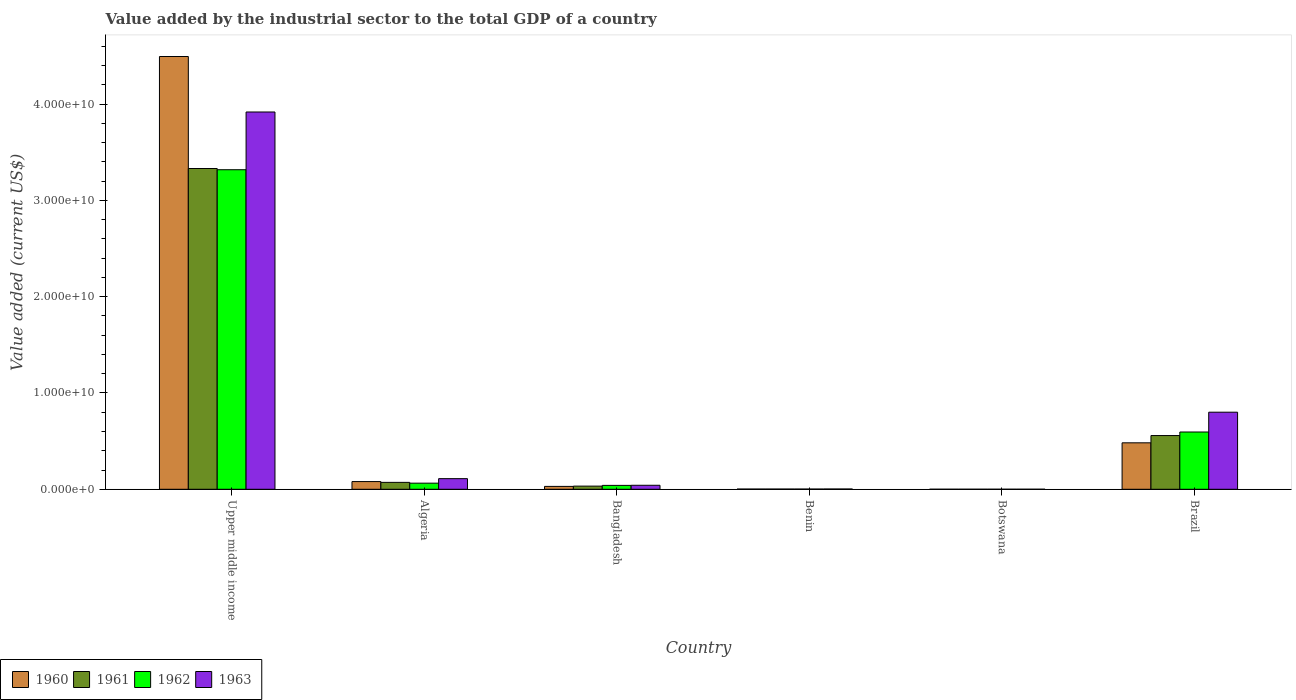Are the number of bars per tick equal to the number of legend labels?
Provide a short and direct response. Yes. Are the number of bars on each tick of the X-axis equal?
Your answer should be very brief. Yes. How many bars are there on the 6th tick from the left?
Your answer should be compact. 4. What is the label of the 4th group of bars from the left?
Ensure brevity in your answer.  Benin. In how many cases, is the number of bars for a given country not equal to the number of legend labels?
Your response must be concise. 0. What is the value added by the industrial sector to the total GDP in 1963 in Botswana?
Offer a terse response. 4.04e+06. Across all countries, what is the maximum value added by the industrial sector to the total GDP in 1961?
Your response must be concise. 3.33e+1. Across all countries, what is the minimum value added by the industrial sector to the total GDP in 1962?
Keep it short and to the point. 4.05e+06. In which country was the value added by the industrial sector to the total GDP in 1962 maximum?
Offer a terse response. Upper middle income. In which country was the value added by the industrial sector to the total GDP in 1960 minimum?
Offer a very short reply. Botswana. What is the total value added by the industrial sector to the total GDP in 1962 in the graph?
Make the answer very short. 4.02e+1. What is the difference between the value added by the industrial sector to the total GDP in 1961 in Brazil and that in Upper middle income?
Offer a terse response. -2.77e+1. What is the difference between the value added by the industrial sector to the total GDP in 1960 in Upper middle income and the value added by the industrial sector to the total GDP in 1963 in Brazil?
Your answer should be compact. 3.69e+1. What is the average value added by the industrial sector to the total GDP in 1960 per country?
Your answer should be very brief. 8.48e+09. What is the difference between the value added by the industrial sector to the total GDP of/in 1960 and value added by the industrial sector to the total GDP of/in 1962 in Upper middle income?
Give a very brief answer. 1.18e+1. In how many countries, is the value added by the industrial sector to the total GDP in 1960 greater than 28000000000 US$?
Ensure brevity in your answer.  1. What is the ratio of the value added by the industrial sector to the total GDP in 1963 in Benin to that in Upper middle income?
Your answer should be very brief. 0. What is the difference between the highest and the second highest value added by the industrial sector to the total GDP in 1960?
Make the answer very short. 4.02e+09. What is the difference between the highest and the lowest value added by the industrial sector to the total GDP in 1962?
Offer a terse response. 3.32e+1. In how many countries, is the value added by the industrial sector to the total GDP in 1961 greater than the average value added by the industrial sector to the total GDP in 1961 taken over all countries?
Your answer should be compact. 1. Is it the case that in every country, the sum of the value added by the industrial sector to the total GDP in 1961 and value added by the industrial sector to the total GDP in 1962 is greater than the sum of value added by the industrial sector to the total GDP in 1960 and value added by the industrial sector to the total GDP in 1963?
Provide a short and direct response. No. Are the values on the major ticks of Y-axis written in scientific E-notation?
Your response must be concise. Yes. Does the graph contain any zero values?
Give a very brief answer. No. Where does the legend appear in the graph?
Your answer should be very brief. Bottom left. How are the legend labels stacked?
Give a very brief answer. Horizontal. What is the title of the graph?
Offer a terse response. Value added by the industrial sector to the total GDP of a country. Does "1964" appear as one of the legend labels in the graph?
Keep it short and to the point. No. What is the label or title of the X-axis?
Keep it short and to the point. Country. What is the label or title of the Y-axis?
Your answer should be very brief. Value added (current US$). What is the Value added (current US$) of 1960 in Upper middle income?
Your answer should be compact. 4.49e+1. What is the Value added (current US$) in 1961 in Upper middle income?
Make the answer very short. 3.33e+1. What is the Value added (current US$) of 1962 in Upper middle income?
Your answer should be very brief. 3.32e+1. What is the Value added (current US$) in 1963 in Upper middle income?
Provide a short and direct response. 3.92e+1. What is the Value added (current US$) in 1960 in Algeria?
Keep it short and to the point. 8.00e+08. What is the Value added (current US$) in 1961 in Algeria?
Provide a succinct answer. 7.17e+08. What is the Value added (current US$) of 1962 in Algeria?
Provide a succinct answer. 6.34e+08. What is the Value added (current US$) in 1963 in Algeria?
Provide a short and direct response. 1.10e+09. What is the Value added (current US$) in 1960 in Bangladesh?
Your response must be concise. 2.98e+08. What is the Value added (current US$) in 1961 in Bangladesh?
Ensure brevity in your answer.  3.27e+08. What is the Value added (current US$) in 1962 in Bangladesh?
Provide a short and direct response. 4.05e+08. What is the Value added (current US$) of 1963 in Bangladesh?
Keep it short and to the point. 4.15e+08. What is the Value added (current US$) in 1960 in Benin?
Ensure brevity in your answer.  2.31e+07. What is the Value added (current US$) of 1961 in Benin?
Offer a very short reply. 2.31e+07. What is the Value added (current US$) of 1962 in Benin?
Ensure brevity in your answer.  2.32e+07. What is the Value added (current US$) in 1963 in Benin?
Give a very brief answer. 2.91e+07. What is the Value added (current US$) of 1960 in Botswana?
Offer a very short reply. 4.05e+06. What is the Value added (current US$) of 1961 in Botswana?
Your response must be concise. 4.05e+06. What is the Value added (current US$) in 1962 in Botswana?
Offer a very short reply. 4.05e+06. What is the Value added (current US$) in 1963 in Botswana?
Make the answer very short. 4.04e+06. What is the Value added (current US$) of 1960 in Brazil?
Your response must be concise. 4.82e+09. What is the Value added (current US$) in 1961 in Brazil?
Your answer should be very brief. 5.58e+09. What is the Value added (current US$) of 1962 in Brazil?
Provide a succinct answer. 5.95e+09. What is the Value added (current US$) of 1963 in Brazil?
Offer a terse response. 8.00e+09. Across all countries, what is the maximum Value added (current US$) of 1960?
Offer a terse response. 4.49e+1. Across all countries, what is the maximum Value added (current US$) of 1961?
Give a very brief answer. 3.33e+1. Across all countries, what is the maximum Value added (current US$) in 1962?
Make the answer very short. 3.32e+1. Across all countries, what is the maximum Value added (current US$) of 1963?
Make the answer very short. 3.92e+1. Across all countries, what is the minimum Value added (current US$) in 1960?
Make the answer very short. 4.05e+06. Across all countries, what is the minimum Value added (current US$) in 1961?
Your response must be concise. 4.05e+06. Across all countries, what is the minimum Value added (current US$) in 1962?
Ensure brevity in your answer.  4.05e+06. Across all countries, what is the minimum Value added (current US$) in 1963?
Offer a terse response. 4.04e+06. What is the total Value added (current US$) in 1960 in the graph?
Provide a short and direct response. 5.09e+1. What is the total Value added (current US$) of 1961 in the graph?
Your answer should be very brief. 4.00e+1. What is the total Value added (current US$) in 1962 in the graph?
Give a very brief answer. 4.02e+1. What is the total Value added (current US$) in 1963 in the graph?
Your response must be concise. 4.87e+1. What is the difference between the Value added (current US$) of 1960 in Upper middle income and that in Algeria?
Provide a short and direct response. 4.41e+1. What is the difference between the Value added (current US$) in 1961 in Upper middle income and that in Algeria?
Offer a terse response. 3.26e+1. What is the difference between the Value added (current US$) of 1962 in Upper middle income and that in Algeria?
Your response must be concise. 3.25e+1. What is the difference between the Value added (current US$) in 1963 in Upper middle income and that in Algeria?
Provide a succinct answer. 3.81e+1. What is the difference between the Value added (current US$) in 1960 in Upper middle income and that in Bangladesh?
Make the answer very short. 4.46e+1. What is the difference between the Value added (current US$) of 1961 in Upper middle income and that in Bangladesh?
Provide a succinct answer. 3.30e+1. What is the difference between the Value added (current US$) in 1962 in Upper middle income and that in Bangladesh?
Give a very brief answer. 3.28e+1. What is the difference between the Value added (current US$) of 1963 in Upper middle income and that in Bangladesh?
Your response must be concise. 3.88e+1. What is the difference between the Value added (current US$) in 1960 in Upper middle income and that in Benin?
Your answer should be compact. 4.49e+1. What is the difference between the Value added (current US$) in 1961 in Upper middle income and that in Benin?
Keep it short and to the point. 3.33e+1. What is the difference between the Value added (current US$) of 1962 in Upper middle income and that in Benin?
Provide a succinct answer. 3.32e+1. What is the difference between the Value added (current US$) of 1963 in Upper middle income and that in Benin?
Give a very brief answer. 3.91e+1. What is the difference between the Value added (current US$) of 1960 in Upper middle income and that in Botswana?
Give a very brief answer. 4.49e+1. What is the difference between the Value added (current US$) in 1961 in Upper middle income and that in Botswana?
Provide a short and direct response. 3.33e+1. What is the difference between the Value added (current US$) in 1962 in Upper middle income and that in Botswana?
Offer a terse response. 3.32e+1. What is the difference between the Value added (current US$) in 1963 in Upper middle income and that in Botswana?
Provide a short and direct response. 3.92e+1. What is the difference between the Value added (current US$) of 1960 in Upper middle income and that in Brazil?
Offer a very short reply. 4.01e+1. What is the difference between the Value added (current US$) of 1961 in Upper middle income and that in Brazil?
Your answer should be compact. 2.77e+1. What is the difference between the Value added (current US$) in 1962 in Upper middle income and that in Brazil?
Offer a terse response. 2.72e+1. What is the difference between the Value added (current US$) of 1963 in Upper middle income and that in Brazil?
Give a very brief answer. 3.12e+1. What is the difference between the Value added (current US$) of 1960 in Algeria and that in Bangladesh?
Offer a terse response. 5.02e+08. What is the difference between the Value added (current US$) in 1961 in Algeria and that in Bangladesh?
Give a very brief answer. 3.90e+08. What is the difference between the Value added (current US$) of 1962 in Algeria and that in Bangladesh?
Ensure brevity in your answer.  2.30e+08. What is the difference between the Value added (current US$) of 1963 in Algeria and that in Bangladesh?
Keep it short and to the point. 6.88e+08. What is the difference between the Value added (current US$) of 1960 in Algeria and that in Benin?
Offer a very short reply. 7.77e+08. What is the difference between the Value added (current US$) of 1961 in Algeria and that in Benin?
Give a very brief answer. 6.94e+08. What is the difference between the Value added (current US$) in 1962 in Algeria and that in Benin?
Your answer should be compact. 6.11e+08. What is the difference between the Value added (current US$) of 1963 in Algeria and that in Benin?
Provide a short and direct response. 1.07e+09. What is the difference between the Value added (current US$) in 1960 in Algeria and that in Botswana?
Keep it short and to the point. 7.96e+08. What is the difference between the Value added (current US$) in 1961 in Algeria and that in Botswana?
Your response must be concise. 7.13e+08. What is the difference between the Value added (current US$) of 1962 in Algeria and that in Botswana?
Provide a short and direct response. 6.30e+08. What is the difference between the Value added (current US$) in 1963 in Algeria and that in Botswana?
Offer a very short reply. 1.10e+09. What is the difference between the Value added (current US$) in 1960 in Algeria and that in Brazil?
Give a very brief answer. -4.02e+09. What is the difference between the Value added (current US$) in 1961 in Algeria and that in Brazil?
Provide a succinct answer. -4.86e+09. What is the difference between the Value added (current US$) of 1962 in Algeria and that in Brazil?
Your answer should be very brief. -5.31e+09. What is the difference between the Value added (current US$) of 1963 in Algeria and that in Brazil?
Keep it short and to the point. -6.90e+09. What is the difference between the Value added (current US$) in 1960 in Bangladesh and that in Benin?
Offer a very short reply. 2.75e+08. What is the difference between the Value added (current US$) in 1961 in Bangladesh and that in Benin?
Provide a short and direct response. 3.04e+08. What is the difference between the Value added (current US$) of 1962 in Bangladesh and that in Benin?
Offer a terse response. 3.82e+08. What is the difference between the Value added (current US$) of 1963 in Bangladesh and that in Benin?
Your answer should be compact. 3.86e+08. What is the difference between the Value added (current US$) in 1960 in Bangladesh and that in Botswana?
Give a very brief answer. 2.94e+08. What is the difference between the Value added (current US$) in 1961 in Bangladesh and that in Botswana?
Your answer should be very brief. 3.23e+08. What is the difference between the Value added (current US$) in 1962 in Bangladesh and that in Botswana?
Your response must be concise. 4.01e+08. What is the difference between the Value added (current US$) in 1963 in Bangladesh and that in Botswana?
Your answer should be compact. 4.11e+08. What is the difference between the Value added (current US$) of 1960 in Bangladesh and that in Brazil?
Keep it short and to the point. -4.52e+09. What is the difference between the Value added (current US$) in 1961 in Bangladesh and that in Brazil?
Keep it short and to the point. -5.25e+09. What is the difference between the Value added (current US$) of 1962 in Bangladesh and that in Brazil?
Provide a short and direct response. -5.54e+09. What is the difference between the Value added (current US$) of 1963 in Bangladesh and that in Brazil?
Your response must be concise. -7.59e+09. What is the difference between the Value added (current US$) of 1960 in Benin and that in Botswana?
Your response must be concise. 1.91e+07. What is the difference between the Value added (current US$) of 1961 in Benin and that in Botswana?
Provide a short and direct response. 1.91e+07. What is the difference between the Value added (current US$) in 1962 in Benin and that in Botswana?
Provide a succinct answer. 1.91e+07. What is the difference between the Value added (current US$) in 1963 in Benin and that in Botswana?
Offer a terse response. 2.51e+07. What is the difference between the Value added (current US$) of 1960 in Benin and that in Brazil?
Your answer should be compact. -4.80e+09. What is the difference between the Value added (current US$) of 1961 in Benin and that in Brazil?
Give a very brief answer. -5.55e+09. What is the difference between the Value added (current US$) in 1962 in Benin and that in Brazil?
Your answer should be very brief. -5.92e+09. What is the difference between the Value added (current US$) of 1963 in Benin and that in Brazil?
Provide a short and direct response. -7.97e+09. What is the difference between the Value added (current US$) in 1960 in Botswana and that in Brazil?
Provide a short and direct response. -4.82e+09. What is the difference between the Value added (current US$) of 1961 in Botswana and that in Brazil?
Your response must be concise. -5.57e+09. What is the difference between the Value added (current US$) in 1962 in Botswana and that in Brazil?
Offer a very short reply. -5.94e+09. What is the difference between the Value added (current US$) in 1963 in Botswana and that in Brazil?
Provide a succinct answer. -8.00e+09. What is the difference between the Value added (current US$) in 1960 in Upper middle income and the Value added (current US$) in 1961 in Algeria?
Offer a terse response. 4.42e+1. What is the difference between the Value added (current US$) of 1960 in Upper middle income and the Value added (current US$) of 1962 in Algeria?
Provide a succinct answer. 4.43e+1. What is the difference between the Value added (current US$) of 1960 in Upper middle income and the Value added (current US$) of 1963 in Algeria?
Your answer should be compact. 4.38e+1. What is the difference between the Value added (current US$) of 1961 in Upper middle income and the Value added (current US$) of 1962 in Algeria?
Your answer should be very brief. 3.27e+1. What is the difference between the Value added (current US$) in 1961 in Upper middle income and the Value added (current US$) in 1963 in Algeria?
Your response must be concise. 3.22e+1. What is the difference between the Value added (current US$) in 1962 in Upper middle income and the Value added (current US$) in 1963 in Algeria?
Your answer should be compact. 3.21e+1. What is the difference between the Value added (current US$) in 1960 in Upper middle income and the Value added (current US$) in 1961 in Bangladesh?
Ensure brevity in your answer.  4.46e+1. What is the difference between the Value added (current US$) in 1960 in Upper middle income and the Value added (current US$) in 1962 in Bangladesh?
Offer a terse response. 4.45e+1. What is the difference between the Value added (current US$) in 1960 in Upper middle income and the Value added (current US$) in 1963 in Bangladesh?
Your answer should be very brief. 4.45e+1. What is the difference between the Value added (current US$) of 1961 in Upper middle income and the Value added (current US$) of 1962 in Bangladesh?
Offer a terse response. 3.29e+1. What is the difference between the Value added (current US$) in 1961 in Upper middle income and the Value added (current US$) in 1963 in Bangladesh?
Make the answer very short. 3.29e+1. What is the difference between the Value added (current US$) in 1962 in Upper middle income and the Value added (current US$) in 1963 in Bangladesh?
Your response must be concise. 3.28e+1. What is the difference between the Value added (current US$) in 1960 in Upper middle income and the Value added (current US$) in 1961 in Benin?
Provide a short and direct response. 4.49e+1. What is the difference between the Value added (current US$) of 1960 in Upper middle income and the Value added (current US$) of 1962 in Benin?
Your answer should be very brief. 4.49e+1. What is the difference between the Value added (current US$) of 1960 in Upper middle income and the Value added (current US$) of 1963 in Benin?
Ensure brevity in your answer.  4.49e+1. What is the difference between the Value added (current US$) of 1961 in Upper middle income and the Value added (current US$) of 1962 in Benin?
Make the answer very short. 3.33e+1. What is the difference between the Value added (current US$) in 1961 in Upper middle income and the Value added (current US$) in 1963 in Benin?
Offer a very short reply. 3.33e+1. What is the difference between the Value added (current US$) in 1962 in Upper middle income and the Value added (current US$) in 1963 in Benin?
Make the answer very short. 3.31e+1. What is the difference between the Value added (current US$) in 1960 in Upper middle income and the Value added (current US$) in 1961 in Botswana?
Make the answer very short. 4.49e+1. What is the difference between the Value added (current US$) of 1960 in Upper middle income and the Value added (current US$) of 1962 in Botswana?
Provide a succinct answer. 4.49e+1. What is the difference between the Value added (current US$) of 1960 in Upper middle income and the Value added (current US$) of 1963 in Botswana?
Offer a terse response. 4.49e+1. What is the difference between the Value added (current US$) of 1961 in Upper middle income and the Value added (current US$) of 1962 in Botswana?
Ensure brevity in your answer.  3.33e+1. What is the difference between the Value added (current US$) of 1961 in Upper middle income and the Value added (current US$) of 1963 in Botswana?
Your answer should be very brief. 3.33e+1. What is the difference between the Value added (current US$) of 1962 in Upper middle income and the Value added (current US$) of 1963 in Botswana?
Your answer should be compact. 3.32e+1. What is the difference between the Value added (current US$) of 1960 in Upper middle income and the Value added (current US$) of 1961 in Brazil?
Ensure brevity in your answer.  3.94e+1. What is the difference between the Value added (current US$) in 1960 in Upper middle income and the Value added (current US$) in 1962 in Brazil?
Make the answer very short. 3.90e+1. What is the difference between the Value added (current US$) in 1960 in Upper middle income and the Value added (current US$) in 1963 in Brazil?
Your answer should be compact. 3.69e+1. What is the difference between the Value added (current US$) of 1961 in Upper middle income and the Value added (current US$) of 1962 in Brazil?
Offer a very short reply. 2.74e+1. What is the difference between the Value added (current US$) of 1961 in Upper middle income and the Value added (current US$) of 1963 in Brazil?
Your response must be concise. 2.53e+1. What is the difference between the Value added (current US$) in 1962 in Upper middle income and the Value added (current US$) in 1963 in Brazil?
Ensure brevity in your answer.  2.52e+1. What is the difference between the Value added (current US$) of 1960 in Algeria and the Value added (current US$) of 1961 in Bangladesh?
Make the answer very short. 4.73e+08. What is the difference between the Value added (current US$) of 1960 in Algeria and the Value added (current US$) of 1962 in Bangladesh?
Your answer should be compact. 3.95e+08. What is the difference between the Value added (current US$) of 1960 in Algeria and the Value added (current US$) of 1963 in Bangladesh?
Keep it short and to the point. 3.85e+08. What is the difference between the Value added (current US$) of 1961 in Algeria and the Value added (current US$) of 1962 in Bangladesh?
Ensure brevity in your answer.  3.12e+08. What is the difference between the Value added (current US$) in 1961 in Algeria and the Value added (current US$) in 1963 in Bangladesh?
Offer a very short reply. 3.02e+08. What is the difference between the Value added (current US$) in 1962 in Algeria and the Value added (current US$) in 1963 in Bangladesh?
Your answer should be very brief. 2.19e+08. What is the difference between the Value added (current US$) in 1960 in Algeria and the Value added (current US$) in 1961 in Benin?
Keep it short and to the point. 7.77e+08. What is the difference between the Value added (current US$) of 1960 in Algeria and the Value added (current US$) of 1962 in Benin?
Make the answer very short. 7.77e+08. What is the difference between the Value added (current US$) in 1960 in Algeria and the Value added (current US$) in 1963 in Benin?
Your answer should be very brief. 7.71e+08. What is the difference between the Value added (current US$) of 1961 in Algeria and the Value added (current US$) of 1962 in Benin?
Your answer should be very brief. 6.94e+08. What is the difference between the Value added (current US$) in 1961 in Algeria and the Value added (current US$) in 1963 in Benin?
Provide a short and direct response. 6.88e+08. What is the difference between the Value added (current US$) of 1962 in Algeria and the Value added (current US$) of 1963 in Benin?
Your response must be concise. 6.05e+08. What is the difference between the Value added (current US$) of 1960 in Algeria and the Value added (current US$) of 1961 in Botswana?
Provide a short and direct response. 7.96e+08. What is the difference between the Value added (current US$) in 1960 in Algeria and the Value added (current US$) in 1962 in Botswana?
Provide a succinct answer. 7.96e+08. What is the difference between the Value added (current US$) of 1960 in Algeria and the Value added (current US$) of 1963 in Botswana?
Your answer should be very brief. 7.96e+08. What is the difference between the Value added (current US$) in 1961 in Algeria and the Value added (current US$) in 1962 in Botswana?
Your answer should be very brief. 7.13e+08. What is the difference between the Value added (current US$) in 1961 in Algeria and the Value added (current US$) in 1963 in Botswana?
Provide a short and direct response. 7.13e+08. What is the difference between the Value added (current US$) in 1962 in Algeria and the Value added (current US$) in 1963 in Botswana?
Make the answer very short. 6.30e+08. What is the difference between the Value added (current US$) in 1960 in Algeria and the Value added (current US$) in 1961 in Brazil?
Give a very brief answer. -4.78e+09. What is the difference between the Value added (current US$) in 1960 in Algeria and the Value added (current US$) in 1962 in Brazil?
Your answer should be very brief. -5.15e+09. What is the difference between the Value added (current US$) of 1960 in Algeria and the Value added (current US$) of 1963 in Brazil?
Keep it short and to the point. -7.20e+09. What is the difference between the Value added (current US$) in 1961 in Algeria and the Value added (current US$) in 1962 in Brazil?
Offer a terse response. -5.23e+09. What is the difference between the Value added (current US$) in 1961 in Algeria and the Value added (current US$) in 1963 in Brazil?
Ensure brevity in your answer.  -7.29e+09. What is the difference between the Value added (current US$) of 1962 in Algeria and the Value added (current US$) of 1963 in Brazil?
Give a very brief answer. -7.37e+09. What is the difference between the Value added (current US$) in 1960 in Bangladesh and the Value added (current US$) in 1961 in Benin?
Keep it short and to the point. 2.75e+08. What is the difference between the Value added (current US$) of 1960 in Bangladesh and the Value added (current US$) of 1962 in Benin?
Give a very brief answer. 2.75e+08. What is the difference between the Value added (current US$) of 1960 in Bangladesh and the Value added (current US$) of 1963 in Benin?
Your response must be concise. 2.69e+08. What is the difference between the Value added (current US$) of 1961 in Bangladesh and the Value added (current US$) of 1962 in Benin?
Make the answer very short. 3.04e+08. What is the difference between the Value added (current US$) of 1961 in Bangladesh and the Value added (current US$) of 1963 in Benin?
Offer a terse response. 2.98e+08. What is the difference between the Value added (current US$) of 1962 in Bangladesh and the Value added (current US$) of 1963 in Benin?
Ensure brevity in your answer.  3.76e+08. What is the difference between the Value added (current US$) in 1960 in Bangladesh and the Value added (current US$) in 1961 in Botswana?
Offer a very short reply. 2.94e+08. What is the difference between the Value added (current US$) in 1960 in Bangladesh and the Value added (current US$) in 1962 in Botswana?
Offer a very short reply. 2.94e+08. What is the difference between the Value added (current US$) in 1960 in Bangladesh and the Value added (current US$) in 1963 in Botswana?
Offer a very short reply. 2.94e+08. What is the difference between the Value added (current US$) in 1961 in Bangladesh and the Value added (current US$) in 1962 in Botswana?
Offer a very short reply. 3.23e+08. What is the difference between the Value added (current US$) of 1961 in Bangladesh and the Value added (current US$) of 1963 in Botswana?
Ensure brevity in your answer.  3.23e+08. What is the difference between the Value added (current US$) of 1962 in Bangladesh and the Value added (current US$) of 1963 in Botswana?
Your answer should be compact. 4.01e+08. What is the difference between the Value added (current US$) of 1960 in Bangladesh and the Value added (current US$) of 1961 in Brazil?
Your answer should be compact. -5.28e+09. What is the difference between the Value added (current US$) of 1960 in Bangladesh and the Value added (current US$) of 1962 in Brazil?
Your answer should be compact. -5.65e+09. What is the difference between the Value added (current US$) of 1960 in Bangladesh and the Value added (current US$) of 1963 in Brazil?
Offer a terse response. -7.71e+09. What is the difference between the Value added (current US$) in 1961 in Bangladesh and the Value added (current US$) in 1962 in Brazil?
Offer a terse response. -5.62e+09. What is the difference between the Value added (current US$) in 1961 in Bangladesh and the Value added (current US$) in 1963 in Brazil?
Your answer should be compact. -7.68e+09. What is the difference between the Value added (current US$) of 1962 in Bangladesh and the Value added (current US$) of 1963 in Brazil?
Provide a succinct answer. -7.60e+09. What is the difference between the Value added (current US$) in 1960 in Benin and the Value added (current US$) in 1961 in Botswana?
Offer a terse response. 1.91e+07. What is the difference between the Value added (current US$) of 1960 in Benin and the Value added (current US$) of 1962 in Botswana?
Ensure brevity in your answer.  1.91e+07. What is the difference between the Value added (current US$) in 1960 in Benin and the Value added (current US$) in 1963 in Botswana?
Your response must be concise. 1.91e+07. What is the difference between the Value added (current US$) of 1961 in Benin and the Value added (current US$) of 1962 in Botswana?
Keep it short and to the point. 1.91e+07. What is the difference between the Value added (current US$) in 1961 in Benin and the Value added (current US$) in 1963 in Botswana?
Your answer should be compact. 1.91e+07. What is the difference between the Value added (current US$) of 1962 in Benin and the Value added (current US$) of 1963 in Botswana?
Ensure brevity in your answer.  1.91e+07. What is the difference between the Value added (current US$) of 1960 in Benin and the Value added (current US$) of 1961 in Brazil?
Provide a short and direct response. -5.55e+09. What is the difference between the Value added (current US$) in 1960 in Benin and the Value added (current US$) in 1962 in Brazil?
Offer a terse response. -5.92e+09. What is the difference between the Value added (current US$) of 1960 in Benin and the Value added (current US$) of 1963 in Brazil?
Offer a terse response. -7.98e+09. What is the difference between the Value added (current US$) in 1961 in Benin and the Value added (current US$) in 1962 in Brazil?
Your response must be concise. -5.92e+09. What is the difference between the Value added (current US$) in 1961 in Benin and the Value added (current US$) in 1963 in Brazil?
Provide a succinct answer. -7.98e+09. What is the difference between the Value added (current US$) of 1962 in Benin and the Value added (current US$) of 1963 in Brazil?
Keep it short and to the point. -7.98e+09. What is the difference between the Value added (current US$) of 1960 in Botswana and the Value added (current US$) of 1961 in Brazil?
Provide a short and direct response. -5.57e+09. What is the difference between the Value added (current US$) of 1960 in Botswana and the Value added (current US$) of 1962 in Brazil?
Provide a short and direct response. -5.94e+09. What is the difference between the Value added (current US$) of 1960 in Botswana and the Value added (current US$) of 1963 in Brazil?
Offer a terse response. -8.00e+09. What is the difference between the Value added (current US$) in 1961 in Botswana and the Value added (current US$) in 1962 in Brazil?
Your response must be concise. -5.94e+09. What is the difference between the Value added (current US$) in 1961 in Botswana and the Value added (current US$) in 1963 in Brazil?
Keep it short and to the point. -8.00e+09. What is the difference between the Value added (current US$) in 1962 in Botswana and the Value added (current US$) in 1963 in Brazil?
Your response must be concise. -8.00e+09. What is the average Value added (current US$) in 1960 per country?
Offer a terse response. 8.48e+09. What is the average Value added (current US$) in 1961 per country?
Provide a succinct answer. 6.66e+09. What is the average Value added (current US$) of 1962 per country?
Your answer should be very brief. 6.70e+09. What is the average Value added (current US$) in 1963 per country?
Keep it short and to the point. 8.12e+09. What is the difference between the Value added (current US$) of 1960 and Value added (current US$) of 1961 in Upper middle income?
Keep it short and to the point. 1.16e+1. What is the difference between the Value added (current US$) in 1960 and Value added (current US$) in 1962 in Upper middle income?
Your response must be concise. 1.18e+1. What is the difference between the Value added (current US$) of 1960 and Value added (current US$) of 1963 in Upper middle income?
Provide a succinct answer. 5.76e+09. What is the difference between the Value added (current US$) in 1961 and Value added (current US$) in 1962 in Upper middle income?
Your answer should be compact. 1.26e+08. What is the difference between the Value added (current US$) of 1961 and Value added (current US$) of 1963 in Upper middle income?
Offer a terse response. -5.87e+09. What is the difference between the Value added (current US$) in 1962 and Value added (current US$) in 1963 in Upper middle income?
Your answer should be compact. -5.99e+09. What is the difference between the Value added (current US$) in 1960 and Value added (current US$) in 1961 in Algeria?
Your response must be concise. 8.27e+07. What is the difference between the Value added (current US$) in 1960 and Value added (current US$) in 1962 in Algeria?
Provide a short and direct response. 1.65e+08. What is the difference between the Value added (current US$) of 1960 and Value added (current US$) of 1963 in Algeria?
Offer a very short reply. -3.03e+08. What is the difference between the Value added (current US$) in 1961 and Value added (current US$) in 1962 in Algeria?
Provide a succinct answer. 8.27e+07. What is the difference between the Value added (current US$) of 1961 and Value added (current US$) of 1963 in Algeria?
Your answer should be compact. -3.86e+08. What is the difference between the Value added (current US$) in 1962 and Value added (current US$) in 1963 in Algeria?
Your answer should be very brief. -4.69e+08. What is the difference between the Value added (current US$) of 1960 and Value added (current US$) of 1961 in Bangladesh?
Your answer should be very brief. -2.92e+07. What is the difference between the Value added (current US$) in 1960 and Value added (current US$) in 1962 in Bangladesh?
Offer a very short reply. -1.07e+08. What is the difference between the Value added (current US$) in 1960 and Value added (current US$) in 1963 in Bangladesh?
Offer a terse response. -1.17e+08. What is the difference between the Value added (current US$) in 1961 and Value added (current US$) in 1962 in Bangladesh?
Your response must be concise. -7.74e+07. What is the difference between the Value added (current US$) in 1961 and Value added (current US$) in 1963 in Bangladesh?
Your response must be concise. -8.78e+07. What is the difference between the Value added (current US$) in 1962 and Value added (current US$) in 1963 in Bangladesh?
Keep it short and to the point. -1.05e+07. What is the difference between the Value added (current US$) in 1960 and Value added (current US$) in 1961 in Benin?
Your response must be concise. 6130.83. What is the difference between the Value added (current US$) in 1960 and Value added (current US$) in 1962 in Benin?
Keep it short and to the point. -1.71e+04. What is the difference between the Value added (current US$) of 1960 and Value added (current US$) of 1963 in Benin?
Ensure brevity in your answer.  -5.99e+06. What is the difference between the Value added (current US$) in 1961 and Value added (current US$) in 1962 in Benin?
Give a very brief answer. -2.32e+04. What is the difference between the Value added (current US$) in 1961 and Value added (current US$) in 1963 in Benin?
Ensure brevity in your answer.  -6.00e+06. What is the difference between the Value added (current US$) of 1962 and Value added (current US$) of 1963 in Benin?
Provide a succinct answer. -5.97e+06. What is the difference between the Value added (current US$) in 1960 and Value added (current US$) in 1961 in Botswana?
Ensure brevity in your answer.  7791.27. What is the difference between the Value added (current US$) in 1960 and Value added (current US$) in 1962 in Botswana?
Offer a very short reply. -314.81. What is the difference between the Value added (current US$) of 1960 and Value added (current US$) of 1963 in Botswana?
Your response must be concise. 1.11e+04. What is the difference between the Value added (current US$) in 1961 and Value added (current US$) in 1962 in Botswana?
Your response must be concise. -8106.08. What is the difference between the Value added (current US$) of 1961 and Value added (current US$) of 1963 in Botswana?
Ensure brevity in your answer.  3353.04. What is the difference between the Value added (current US$) of 1962 and Value added (current US$) of 1963 in Botswana?
Provide a succinct answer. 1.15e+04. What is the difference between the Value added (current US$) in 1960 and Value added (current US$) in 1961 in Brazil?
Offer a very short reply. -7.55e+08. What is the difference between the Value added (current US$) in 1960 and Value added (current US$) in 1962 in Brazil?
Ensure brevity in your answer.  -1.12e+09. What is the difference between the Value added (current US$) of 1960 and Value added (current US$) of 1963 in Brazil?
Ensure brevity in your answer.  -3.18e+09. What is the difference between the Value added (current US$) in 1961 and Value added (current US$) in 1962 in Brazil?
Provide a succinct answer. -3.69e+08. What is the difference between the Value added (current US$) of 1961 and Value added (current US$) of 1963 in Brazil?
Your answer should be compact. -2.43e+09. What is the difference between the Value added (current US$) of 1962 and Value added (current US$) of 1963 in Brazil?
Offer a very short reply. -2.06e+09. What is the ratio of the Value added (current US$) in 1960 in Upper middle income to that in Algeria?
Keep it short and to the point. 56.17. What is the ratio of the Value added (current US$) of 1961 in Upper middle income to that in Algeria?
Offer a very short reply. 46.44. What is the ratio of the Value added (current US$) of 1962 in Upper middle income to that in Algeria?
Your response must be concise. 52.3. What is the ratio of the Value added (current US$) of 1963 in Upper middle income to that in Algeria?
Your response must be concise. 35.5. What is the ratio of the Value added (current US$) in 1960 in Upper middle income to that in Bangladesh?
Give a very brief answer. 150.72. What is the ratio of the Value added (current US$) of 1961 in Upper middle income to that in Bangladesh?
Make the answer very short. 101.75. What is the ratio of the Value added (current US$) in 1962 in Upper middle income to that in Bangladesh?
Offer a terse response. 81.99. What is the ratio of the Value added (current US$) in 1963 in Upper middle income to that in Bangladesh?
Make the answer very short. 94.36. What is the ratio of the Value added (current US$) in 1960 in Upper middle income to that in Benin?
Offer a very short reply. 1942.42. What is the ratio of the Value added (current US$) in 1961 in Upper middle income to that in Benin?
Offer a very short reply. 1440.1. What is the ratio of the Value added (current US$) in 1962 in Upper middle income to that in Benin?
Your answer should be compact. 1433.2. What is the ratio of the Value added (current US$) of 1963 in Upper middle income to that in Benin?
Provide a short and direct response. 1345.05. What is the ratio of the Value added (current US$) in 1960 in Upper middle income to that in Botswana?
Give a very brief answer. 1.11e+04. What is the ratio of the Value added (current US$) of 1961 in Upper middle income to that in Botswana?
Keep it short and to the point. 8231.16. What is the ratio of the Value added (current US$) of 1962 in Upper middle income to that in Botswana?
Your answer should be compact. 8183.55. What is the ratio of the Value added (current US$) of 1963 in Upper middle income to that in Botswana?
Provide a succinct answer. 9689.55. What is the ratio of the Value added (current US$) in 1960 in Upper middle income to that in Brazil?
Give a very brief answer. 9.32. What is the ratio of the Value added (current US$) of 1961 in Upper middle income to that in Brazil?
Give a very brief answer. 5.97. What is the ratio of the Value added (current US$) in 1962 in Upper middle income to that in Brazil?
Offer a very short reply. 5.58. What is the ratio of the Value added (current US$) of 1963 in Upper middle income to that in Brazil?
Your answer should be very brief. 4.89. What is the ratio of the Value added (current US$) of 1960 in Algeria to that in Bangladesh?
Ensure brevity in your answer.  2.68. What is the ratio of the Value added (current US$) in 1961 in Algeria to that in Bangladesh?
Ensure brevity in your answer.  2.19. What is the ratio of the Value added (current US$) of 1962 in Algeria to that in Bangladesh?
Make the answer very short. 1.57. What is the ratio of the Value added (current US$) in 1963 in Algeria to that in Bangladesh?
Keep it short and to the point. 2.66. What is the ratio of the Value added (current US$) in 1960 in Algeria to that in Benin?
Your answer should be very brief. 34.58. What is the ratio of the Value added (current US$) of 1961 in Algeria to that in Benin?
Give a very brief answer. 31.01. What is the ratio of the Value added (current US$) in 1962 in Algeria to that in Benin?
Make the answer very short. 27.4. What is the ratio of the Value added (current US$) in 1963 in Algeria to that in Benin?
Your response must be concise. 37.88. What is the ratio of the Value added (current US$) in 1960 in Algeria to that in Botswana?
Your answer should be compact. 197.31. What is the ratio of the Value added (current US$) of 1961 in Algeria to that in Botswana?
Ensure brevity in your answer.  177.24. What is the ratio of the Value added (current US$) of 1962 in Algeria to that in Botswana?
Provide a short and direct response. 156.48. What is the ratio of the Value added (current US$) of 1963 in Algeria to that in Botswana?
Provide a succinct answer. 272.91. What is the ratio of the Value added (current US$) of 1960 in Algeria to that in Brazil?
Your answer should be compact. 0.17. What is the ratio of the Value added (current US$) in 1961 in Algeria to that in Brazil?
Your response must be concise. 0.13. What is the ratio of the Value added (current US$) in 1962 in Algeria to that in Brazil?
Offer a terse response. 0.11. What is the ratio of the Value added (current US$) in 1963 in Algeria to that in Brazil?
Ensure brevity in your answer.  0.14. What is the ratio of the Value added (current US$) in 1960 in Bangladesh to that in Benin?
Your answer should be very brief. 12.89. What is the ratio of the Value added (current US$) in 1961 in Bangladesh to that in Benin?
Keep it short and to the point. 14.15. What is the ratio of the Value added (current US$) in 1962 in Bangladesh to that in Benin?
Provide a succinct answer. 17.48. What is the ratio of the Value added (current US$) of 1963 in Bangladesh to that in Benin?
Provide a succinct answer. 14.26. What is the ratio of the Value added (current US$) of 1960 in Bangladesh to that in Botswana?
Provide a short and direct response. 73.54. What is the ratio of the Value added (current US$) of 1961 in Bangladesh to that in Botswana?
Ensure brevity in your answer.  80.89. What is the ratio of the Value added (current US$) in 1962 in Bangladesh to that in Botswana?
Keep it short and to the point. 99.81. What is the ratio of the Value added (current US$) of 1963 in Bangladesh to that in Botswana?
Ensure brevity in your answer.  102.69. What is the ratio of the Value added (current US$) in 1960 in Bangladesh to that in Brazil?
Keep it short and to the point. 0.06. What is the ratio of the Value added (current US$) in 1961 in Bangladesh to that in Brazil?
Keep it short and to the point. 0.06. What is the ratio of the Value added (current US$) of 1962 in Bangladesh to that in Brazil?
Offer a terse response. 0.07. What is the ratio of the Value added (current US$) of 1963 in Bangladesh to that in Brazil?
Your answer should be compact. 0.05. What is the ratio of the Value added (current US$) of 1960 in Benin to that in Botswana?
Offer a very short reply. 5.71. What is the ratio of the Value added (current US$) of 1961 in Benin to that in Botswana?
Offer a terse response. 5.72. What is the ratio of the Value added (current US$) in 1962 in Benin to that in Botswana?
Ensure brevity in your answer.  5.71. What is the ratio of the Value added (current US$) in 1963 in Benin to that in Botswana?
Keep it short and to the point. 7.2. What is the ratio of the Value added (current US$) of 1960 in Benin to that in Brazil?
Your answer should be compact. 0. What is the ratio of the Value added (current US$) of 1961 in Benin to that in Brazil?
Your answer should be compact. 0. What is the ratio of the Value added (current US$) in 1962 in Benin to that in Brazil?
Keep it short and to the point. 0. What is the ratio of the Value added (current US$) in 1963 in Benin to that in Brazil?
Your answer should be compact. 0. What is the ratio of the Value added (current US$) of 1960 in Botswana to that in Brazil?
Provide a succinct answer. 0. What is the ratio of the Value added (current US$) in 1961 in Botswana to that in Brazil?
Ensure brevity in your answer.  0. What is the ratio of the Value added (current US$) of 1962 in Botswana to that in Brazil?
Provide a short and direct response. 0. What is the difference between the highest and the second highest Value added (current US$) in 1960?
Provide a short and direct response. 4.01e+1. What is the difference between the highest and the second highest Value added (current US$) of 1961?
Make the answer very short. 2.77e+1. What is the difference between the highest and the second highest Value added (current US$) in 1962?
Make the answer very short. 2.72e+1. What is the difference between the highest and the second highest Value added (current US$) of 1963?
Provide a succinct answer. 3.12e+1. What is the difference between the highest and the lowest Value added (current US$) in 1960?
Offer a terse response. 4.49e+1. What is the difference between the highest and the lowest Value added (current US$) in 1961?
Your answer should be compact. 3.33e+1. What is the difference between the highest and the lowest Value added (current US$) in 1962?
Your answer should be very brief. 3.32e+1. What is the difference between the highest and the lowest Value added (current US$) in 1963?
Give a very brief answer. 3.92e+1. 